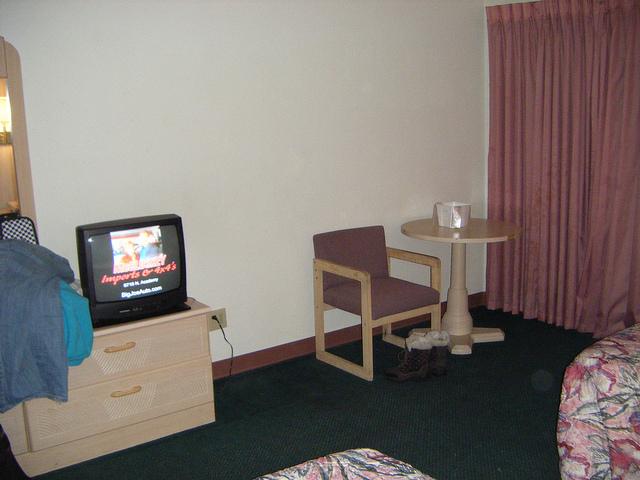What color are the curtains?
Short answer required. Pink. What is this room?
Answer briefly. Hotel. Is the television on?
Keep it brief. Yes. Is this someone's house?
Concise answer only. No. 